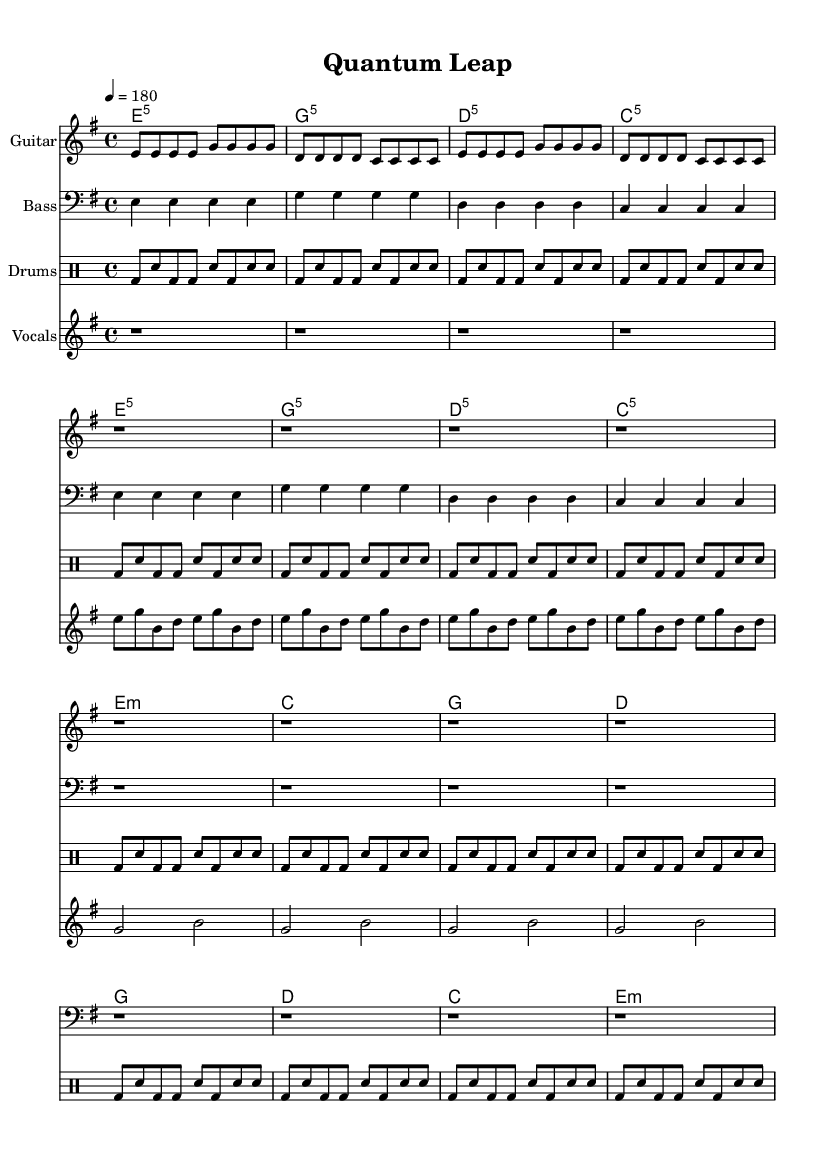What is the key signature of this music? The key signature is E minor, which has one sharp (F#) indicated at the beginning of the staff.
Answer: E minor What is the time signature of this piece? The time signature is 4/4, as shown at the beginning of the notation, indicating four beats per measure.
Answer: 4/4 What is the tempo marking for this piece? The tempo marking is quarter note equals 180, indicating a very fast tempo to match the punk genre.
Answer: 180 How many times is the verse repeated in the score? The verse is indicated to repeat four times in the vocal section, as shown with "repeat unfold 4" in the vocalVerse.
Answer: 4 Which chord follows the G chord in the chorus? Following the G chord in the chorus, the next chord is D, as shown in the chord progression.
Answer: D What is the main theme of the lyrics in the chorus? The thematic focus in the chorus emphasizes innovation and technological advancement, encapsulated in phrases like "quantum leap" and "technology will set us free."
Answer: Innovation What is the structure of the song in terms of sections? The structure consists of verses followed by choruses, with a clear alternation that is typical for punk anthems, which is evident in the arrangement of vocal and chord sections.
Answer: Verse-Chorus 